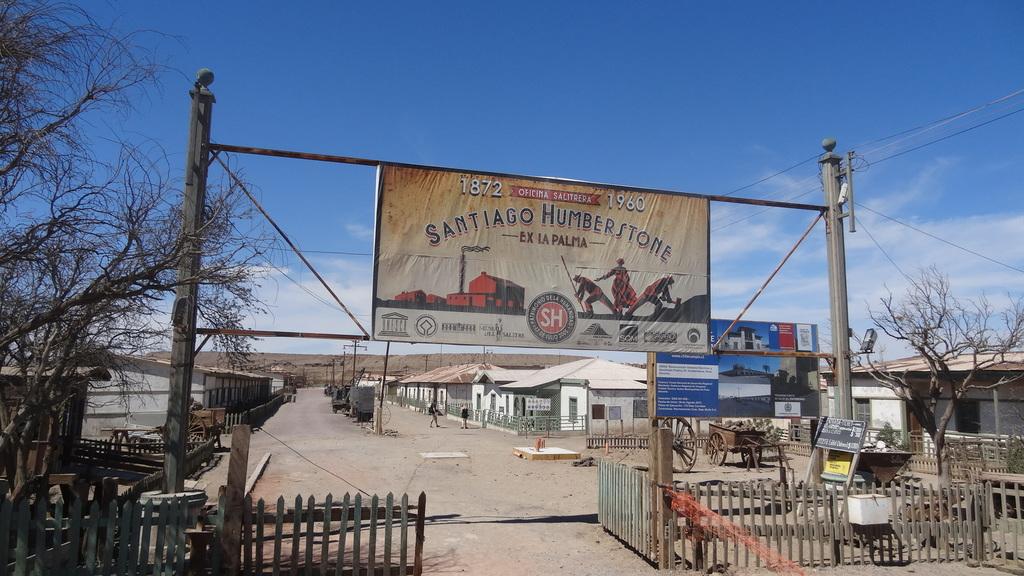When was the banner made?
Make the answer very short. 1960. 